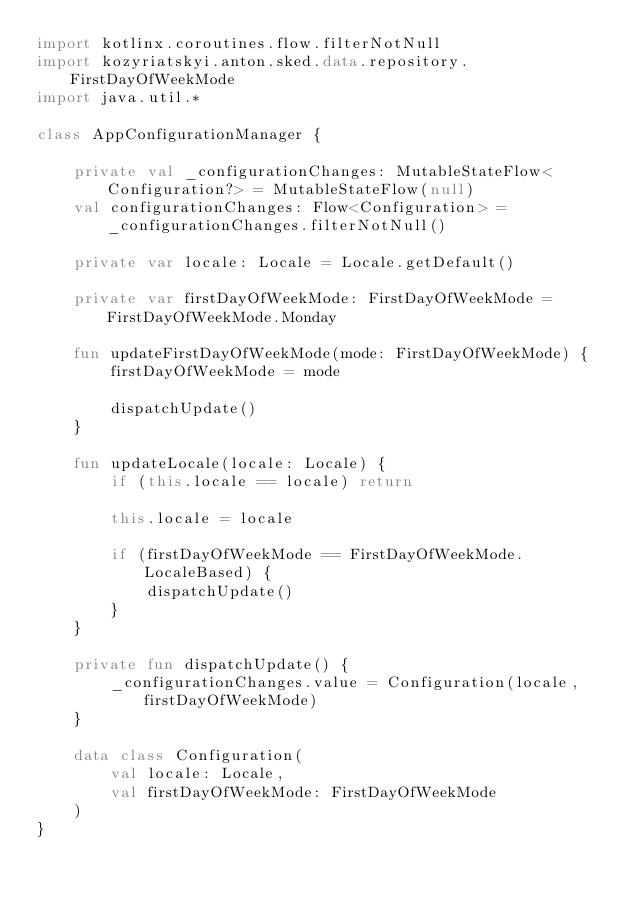<code> <loc_0><loc_0><loc_500><loc_500><_Kotlin_>import kotlinx.coroutines.flow.filterNotNull
import kozyriatskyi.anton.sked.data.repository.FirstDayOfWeekMode
import java.util.*

class AppConfigurationManager {

    private val _configurationChanges: MutableStateFlow<Configuration?> = MutableStateFlow(null)
    val configurationChanges: Flow<Configuration> = _configurationChanges.filterNotNull()

    private var locale: Locale = Locale.getDefault()

    private var firstDayOfWeekMode: FirstDayOfWeekMode = FirstDayOfWeekMode.Monday

    fun updateFirstDayOfWeekMode(mode: FirstDayOfWeekMode) {
        firstDayOfWeekMode = mode

        dispatchUpdate()
    }

    fun updateLocale(locale: Locale) {
        if (this.locale == locale) return

        this.locale = locale

        if (firstDayOfWeekMode == FirstDayOfWeekMode.LocaleBased) {
            dispatchUpdate()
        }
    }

    private fun dispatchUpdate() {
        _configurationChanges.value = Configuration(locale, firstDayOfWeekMode)
    }

    data class Configuration(
        val locale: Locale,
        val firstDayOfWeekMode: FirstDayOfWeekMode
    )
}</code> 